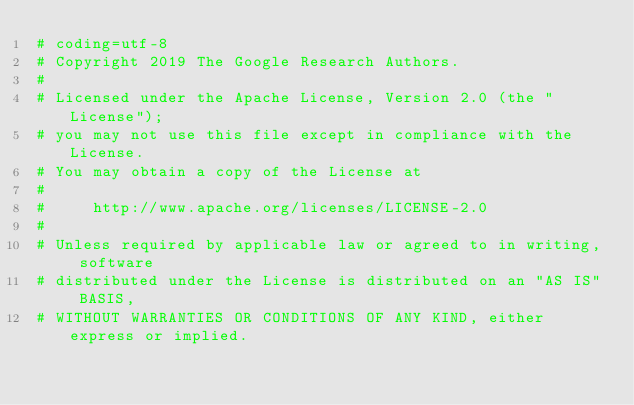Convert code to text. <code><loc_0><loc_0><loc_500><loc_500><_Python_># coding=utf-8
# Copyright 2019 The Google Research Authors.
#
# Licensed under the Apache License, Version 2.0 (the "License");
# you may not use this file except in compliance with the License.
# You may obtain a copy of the License at
#
#     http://www.apache.org/licenses/LICENSE-2.0
#
# Unless required by applicable law or agreed to in writing, software
# distributed under the License is distributed on an "AS IS" BASIS,
# WITHOUT WARRANTIES OR CONDITIONS OF ANY KIND, either express or implied.</code> 